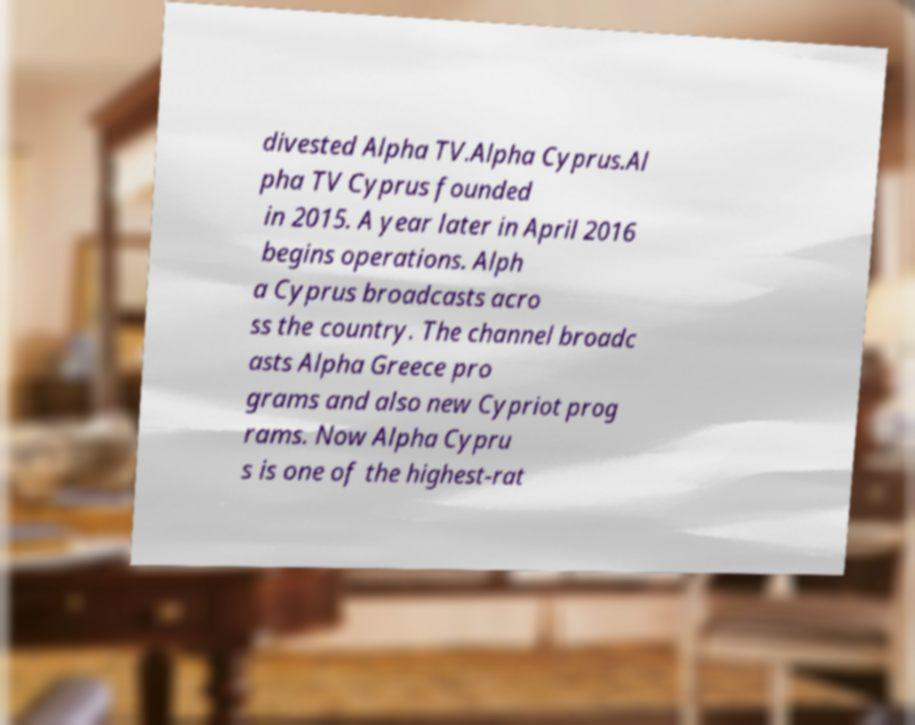There's text embedded in this image that I need extracted. Can you transcribe it verbatim? divested Alpha TV.Alpha Cyprus.Al pha TV Cyprus founded in 2015. A year later in April 2016 begins operations. Alph a Cyprus broadcasts acro ss the country. The channel broadc asts Alpha Greece pro grams and also new Cypriot prog rams. Now Alpha Cypru s is one of the highest-rat 